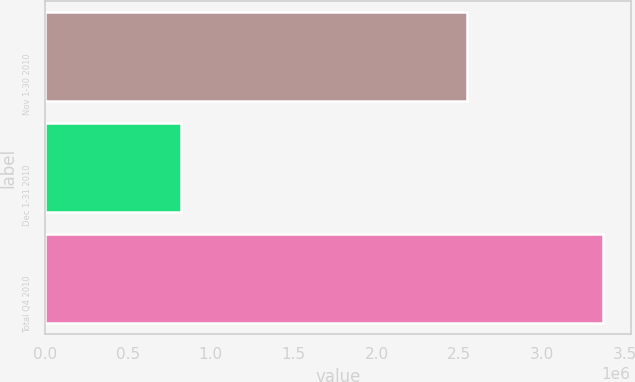Convert chart to OTSL. <chart><loc_0><loc_0><loc_500><loc_500><bar_chart><fcel>Nov 1-30 2010<fcel>Dec 1-31 2010<fcel>Total Q4 2010<nl><fcel>2.54379e+06<fcel>822099<fcel>3.36589e+06<nl></chart> 